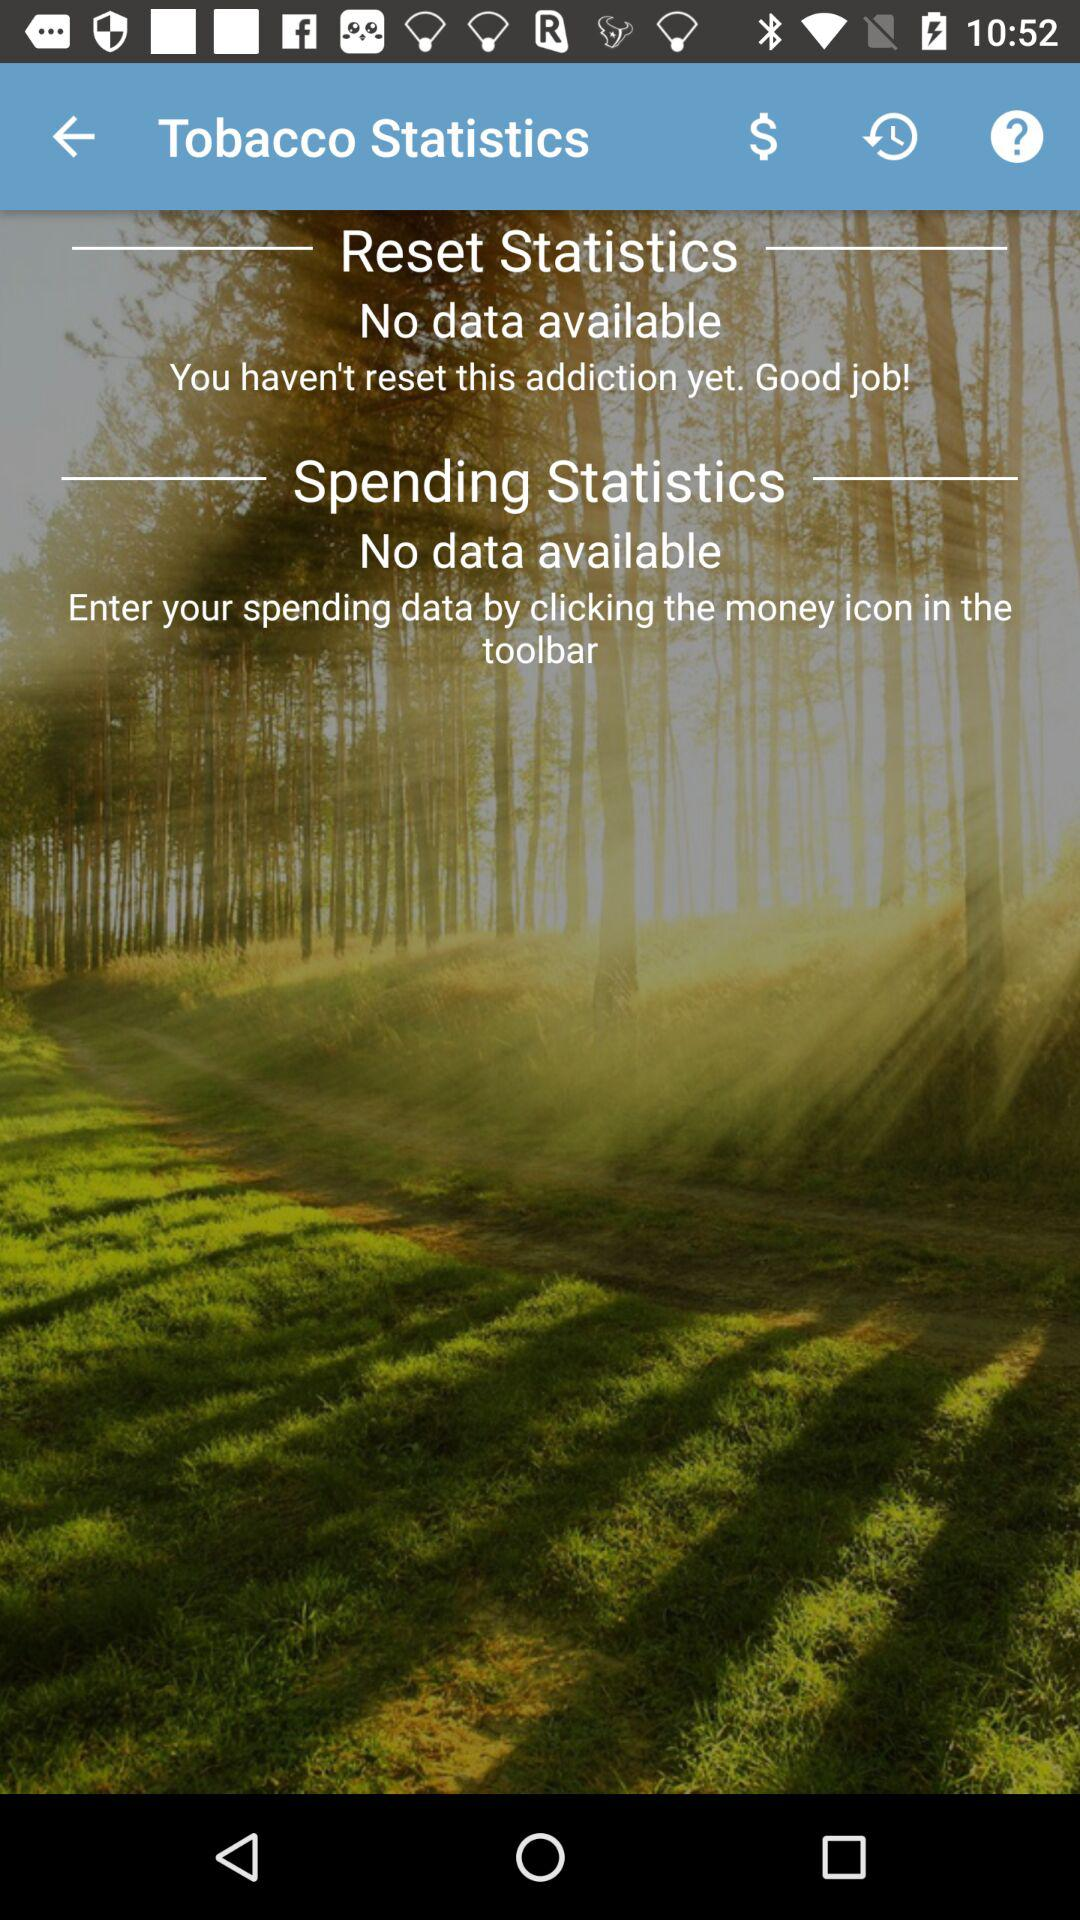How many statistics are shown for tobacco?
Answer the question using a single word or phrase. 2 